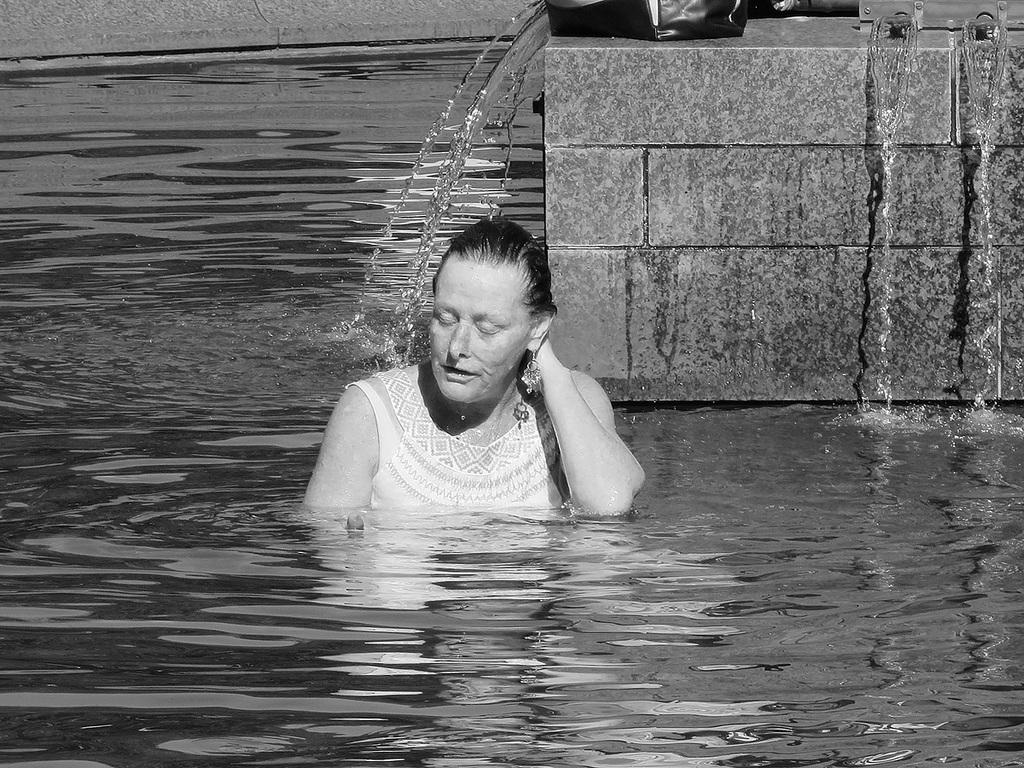Who is present in the image? There is a woman in the image. What is the woman doing in the image? The woman is in water. What else can be seen in the background of the image? There is a bag visible in the background of the image. How does the woman establish a connection with the light in the image? There is no light present in the image, and the woman is not establishing any connections. 